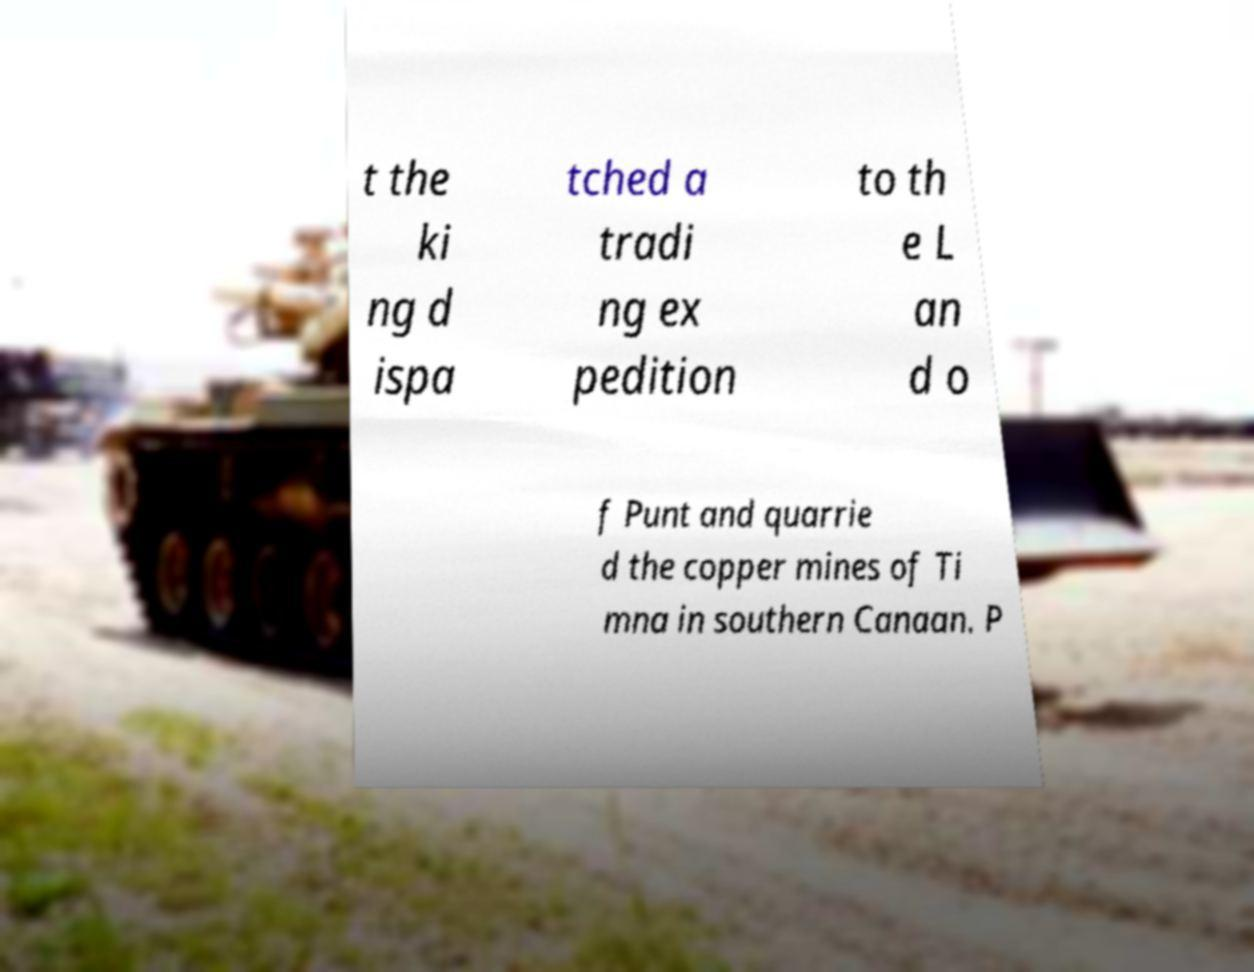I need the written content from this picture converted into text. Can you do that? t the ki ng d ispa tched a tradi ng ex pedition to th e L an d o f Punt and quarrie d the copper mines of Ti mna in southern Canaan. P 